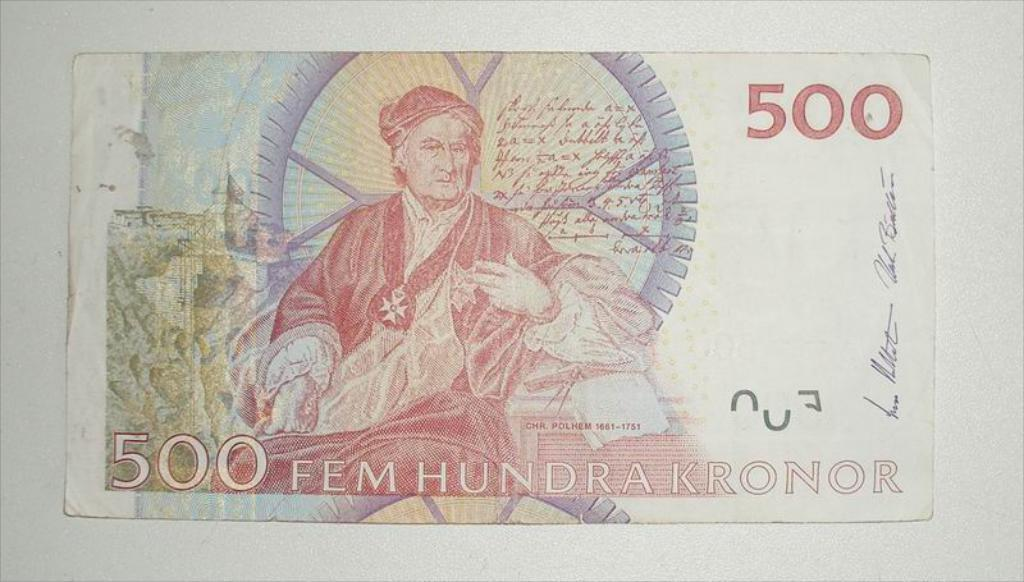What is the main subject of the image? The main subject of the image is a photograph of a foreign currency note. Can you describe any specific details about the note? Yes, the note has "500" written on the front bottom side. What type of horn can be seen on the currency note in the image? There is no horn present on the currency note in the image. What type of wound is visible on the currency note in the image? There are no wounds visible on the currency note in the image. What type of metal is used to make the currency note in the image? Currency notes are typically made of paper or a similar material, not metal. 